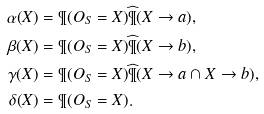<formula> <loc_0><loc_0><loc_500><loc_500>\alpha ( X ) & = \P ( O _ { S } = X ) { \widehat { \P } } ( X \rightarrow a ) , \\ \beta ( X ) & = \P ( O _ { S } = X ) { \widehat { \P } } ( X \rightarrow b ) , \\ \gamma ( X ) & = \P ( O _ { S } = X ) { \widehat { \P } } ( X \rightarrow a \cap X \rightarrow b ) , \\ \delta ( X ) & = \P ( O _ { S } = X ) .</formula> 